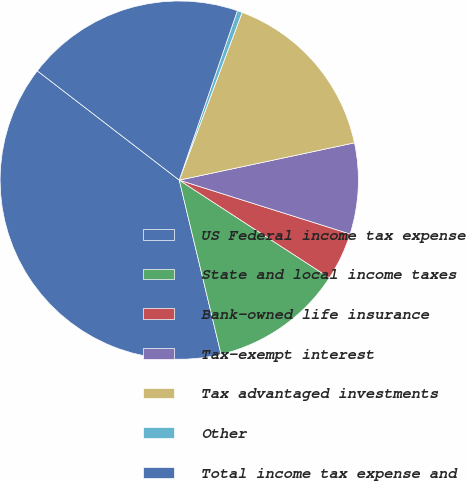Convert chart to OTSL. <chart><loc_0><loc_0><loc_500><loc_500><pie_chart><fcel>US Federal income tax expense<fcel>State and local income taxes<fcel>Bank-owned life insurance<fcel>Tax-exempt interest<fcel>Tax advantaged investments<fcel>Other<fcel>Total income tax expense and<nl><fcel>39.19%<fcel>12.07%<fcel>4.32%<fcel>8.2%<fcel>15.95%<fcel>0.45%<fcel>19.82%<nl></chart> 